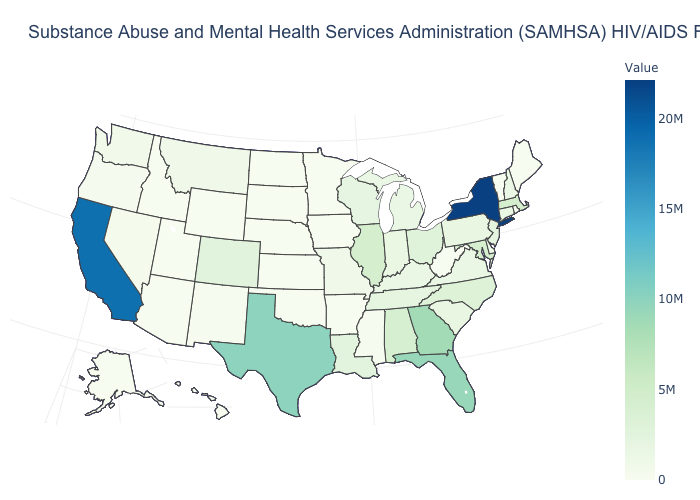Does Maine have a higher value than Ohio?
Answer briefly. No. Among the states that border New Mexico , does Colorado have the lowest value?
Keep it brief. No. Which states have the highest value in the USA?
Be succinct. New York. Which states hav the highest value in the West?
Keep it brief. California. Is the legend a continuous bar?
Answer briefly. Yes. Does Illinois have the lowest value in the MidWest?
Keep it brief. No. 